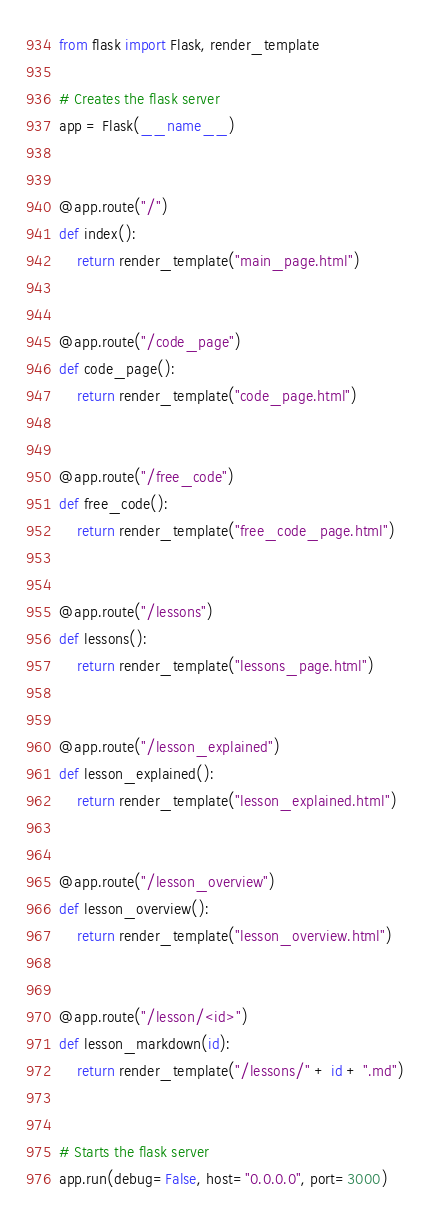Convert code to text. <code><loc_0><loc_0><loc_500><loc_500><_Python_>from flask import Flask, render_template

# Creates the flask server
app = Flask(__name__)


@app.route("/")
def index():
    return render_template("main_page.html")


@app.route("/code_page")
def code_page():
    return render_template("code_page.html")


@app.route("/free_code")
def free_code():
    return render_template("free_code_page.html")


@app.route("/lessons")
def lessons():
    return render_template("lessons_page.html")


@app.route("/lesson_explained")
def lesson_explained():
    return render_template("lesson_explained.html")


@app.route("/lesson_overview")
def lesson_overview():
    return render_template("lesson_overview.html")


@app.route("/lesson/<id>")
def lesson_markdown(id):
    return render_template("/lessons/" + id + ".md")


# Starts the flask server
app.run(debug=False, host="0.0.0.0", port=3000)</code> 